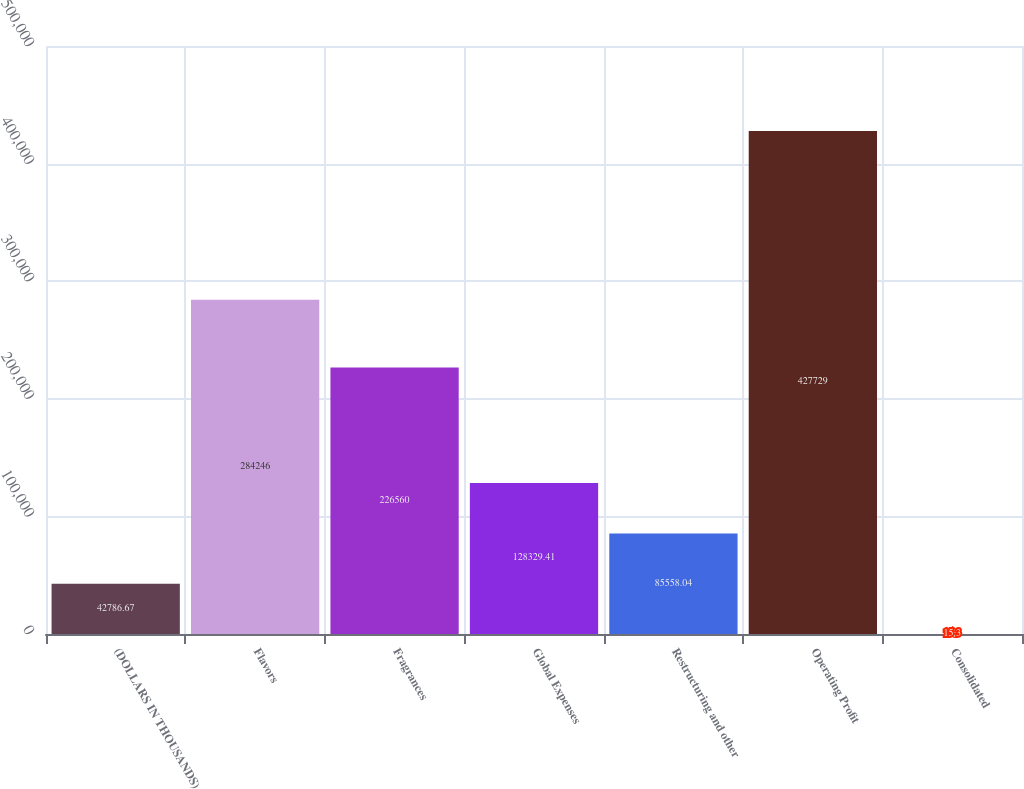Convert chart to OTSL. <chart><loc_0><loc_0><loc_500><loc_500><bar_chart><fcel>(DOLLARS IN THOUSANDS)<fcel>Flavors<fcel>Fragrances<fcel>Global Expenses<fcel>Restructuring and other<fcel>Operating Profit<fcel>Consolidated<nl><fcel>42786.7<fcel>284246<fcel>226560<fcel>128329<fcel>85558<fcel>427729<fcel>15.3<nl></chart> 